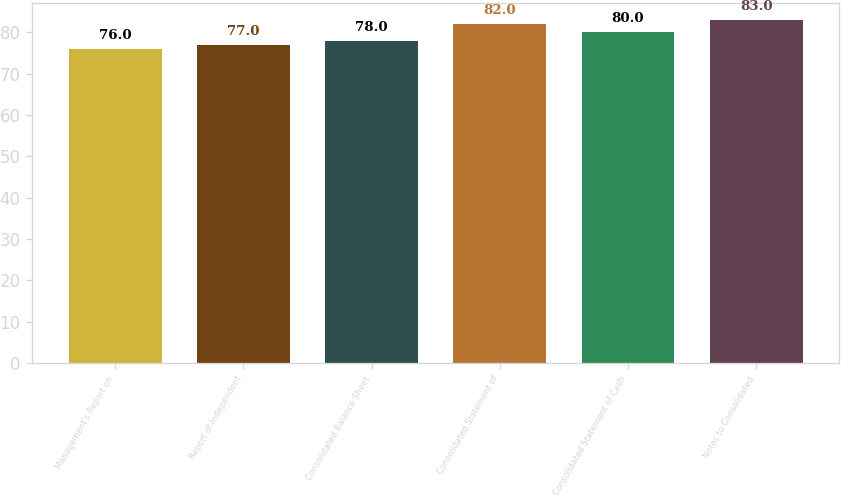Convert chart. <chart><loc_0><loc_0><loc_500><loc_500><bar_chart><fcel>Management's Report on<fcel>Report of Independent<fcel>Consolidated Balance Sheet<fcel>Consolidated Statement of<fcel>Consolidated Statement of Cash<fcel>Notes to Consolidated<nl><fcel>76<fcel>77<fcel>78<fcel>82<fcel>80<fcel>83<nl></chart> 